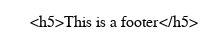<code> <loc_0><loc_0><loc_500><loc_500><_HTML_><h5>This is a footer</h5></code> 